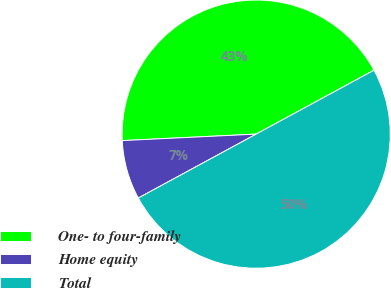Convert chart to OTSL. <chart><loc_0><loc_0><loc_500><loc_500><pie_chart><fcel>One- to four-family<fcel>Home equity<fcel>Total<nl><fcel>42.86%<fcel>7.14%<fcel>50.0%<nl></chart> 